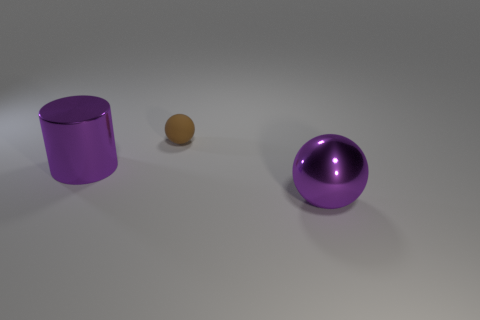What shape is the metal object that is the same color as the big cylinder?
Make the answer very short. Sphere. Are there any large purple objects?
Your response must be concise. Yes. Does the big thing that is right of the rubber thing have the same shape as the tiny thing that is right of the large cylinder?
Your answer should be compact. Yes. Is there a big gray thing made of the same material as the purple cylinder?
Give a very brief answer. No. Are the large purple object right of the big metal cylinder and the tiny brown object made of the same material?
Your answer should be very brief. No. Are there more tiny matte balls that are on the right side of the small matte ball than large cylinders that are to the right of the large ball?
Keep it short and to the point. No. There is a thing that is the same size as the purple ball; what is its color?
Provide a short and direct response. Purple. Are there any big spheres of the same color as the large cylinder?
Your answer should be very brief. Yes. There is a large thing to the right of the matte sphere; is it the same color as the shiny object that is on the left side of the matte object?
Offer a very short reply. Yes. What material is the large purple thing that is on the right side of the small rubber thing?
Your answer should be very brief. Metal. 